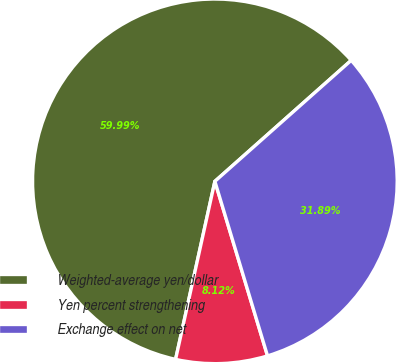<chart> <loc_0><loc_0><loc_500><loc_500><pie_chart><fcel>Weighted-average yen/dollar<fcel>Yen percent strengthening<fcel>Exchange effect on net<nl><fcel>59.99%<fcel>8.12%<fcel>31.89%<nl></chart> 